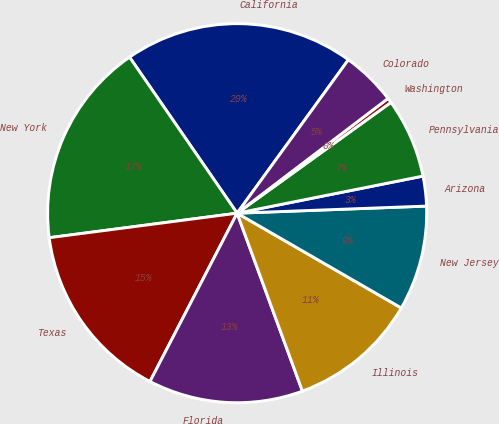Convert chart. <chart><loc_0><loc_0><loc_500><loc_500><pie_chart><fcel>California<fcel>New York<fcel>Texas<fcel>Florida<fcel>Illinois<fcel>New Jersey<fcel>Arizona<fcel>Pennsylvania<fcel>Washington<fcel>Colorado<nl><fcel>19.59%<fcel>17.46%<fcel>15.33%<fcel>13.2%<fcel>11.07%<fcel>8.93%<fcel>2.54%<fcel>6.8%<fcel>0.41%<fcel>4.67%<nl></chart> 